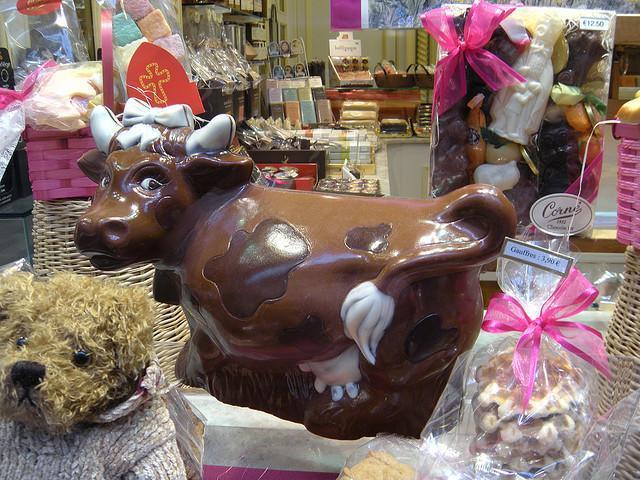Does the caption "The cow is behind the teddy bear." correctly depict the image?
Answer yes or no. Yes. Is the caption "The teddy bear is facing the cow." a true representation of the image?
Answer yes or no. No. 